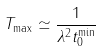Convert formula to latex. <formula><loc_0><loc_0><loc_500><loc_500>T _ { \max } \simeq \frac { 1 } { \lambda ^ { 2 } t _ { 0 } ^ { \min } }</formula> 